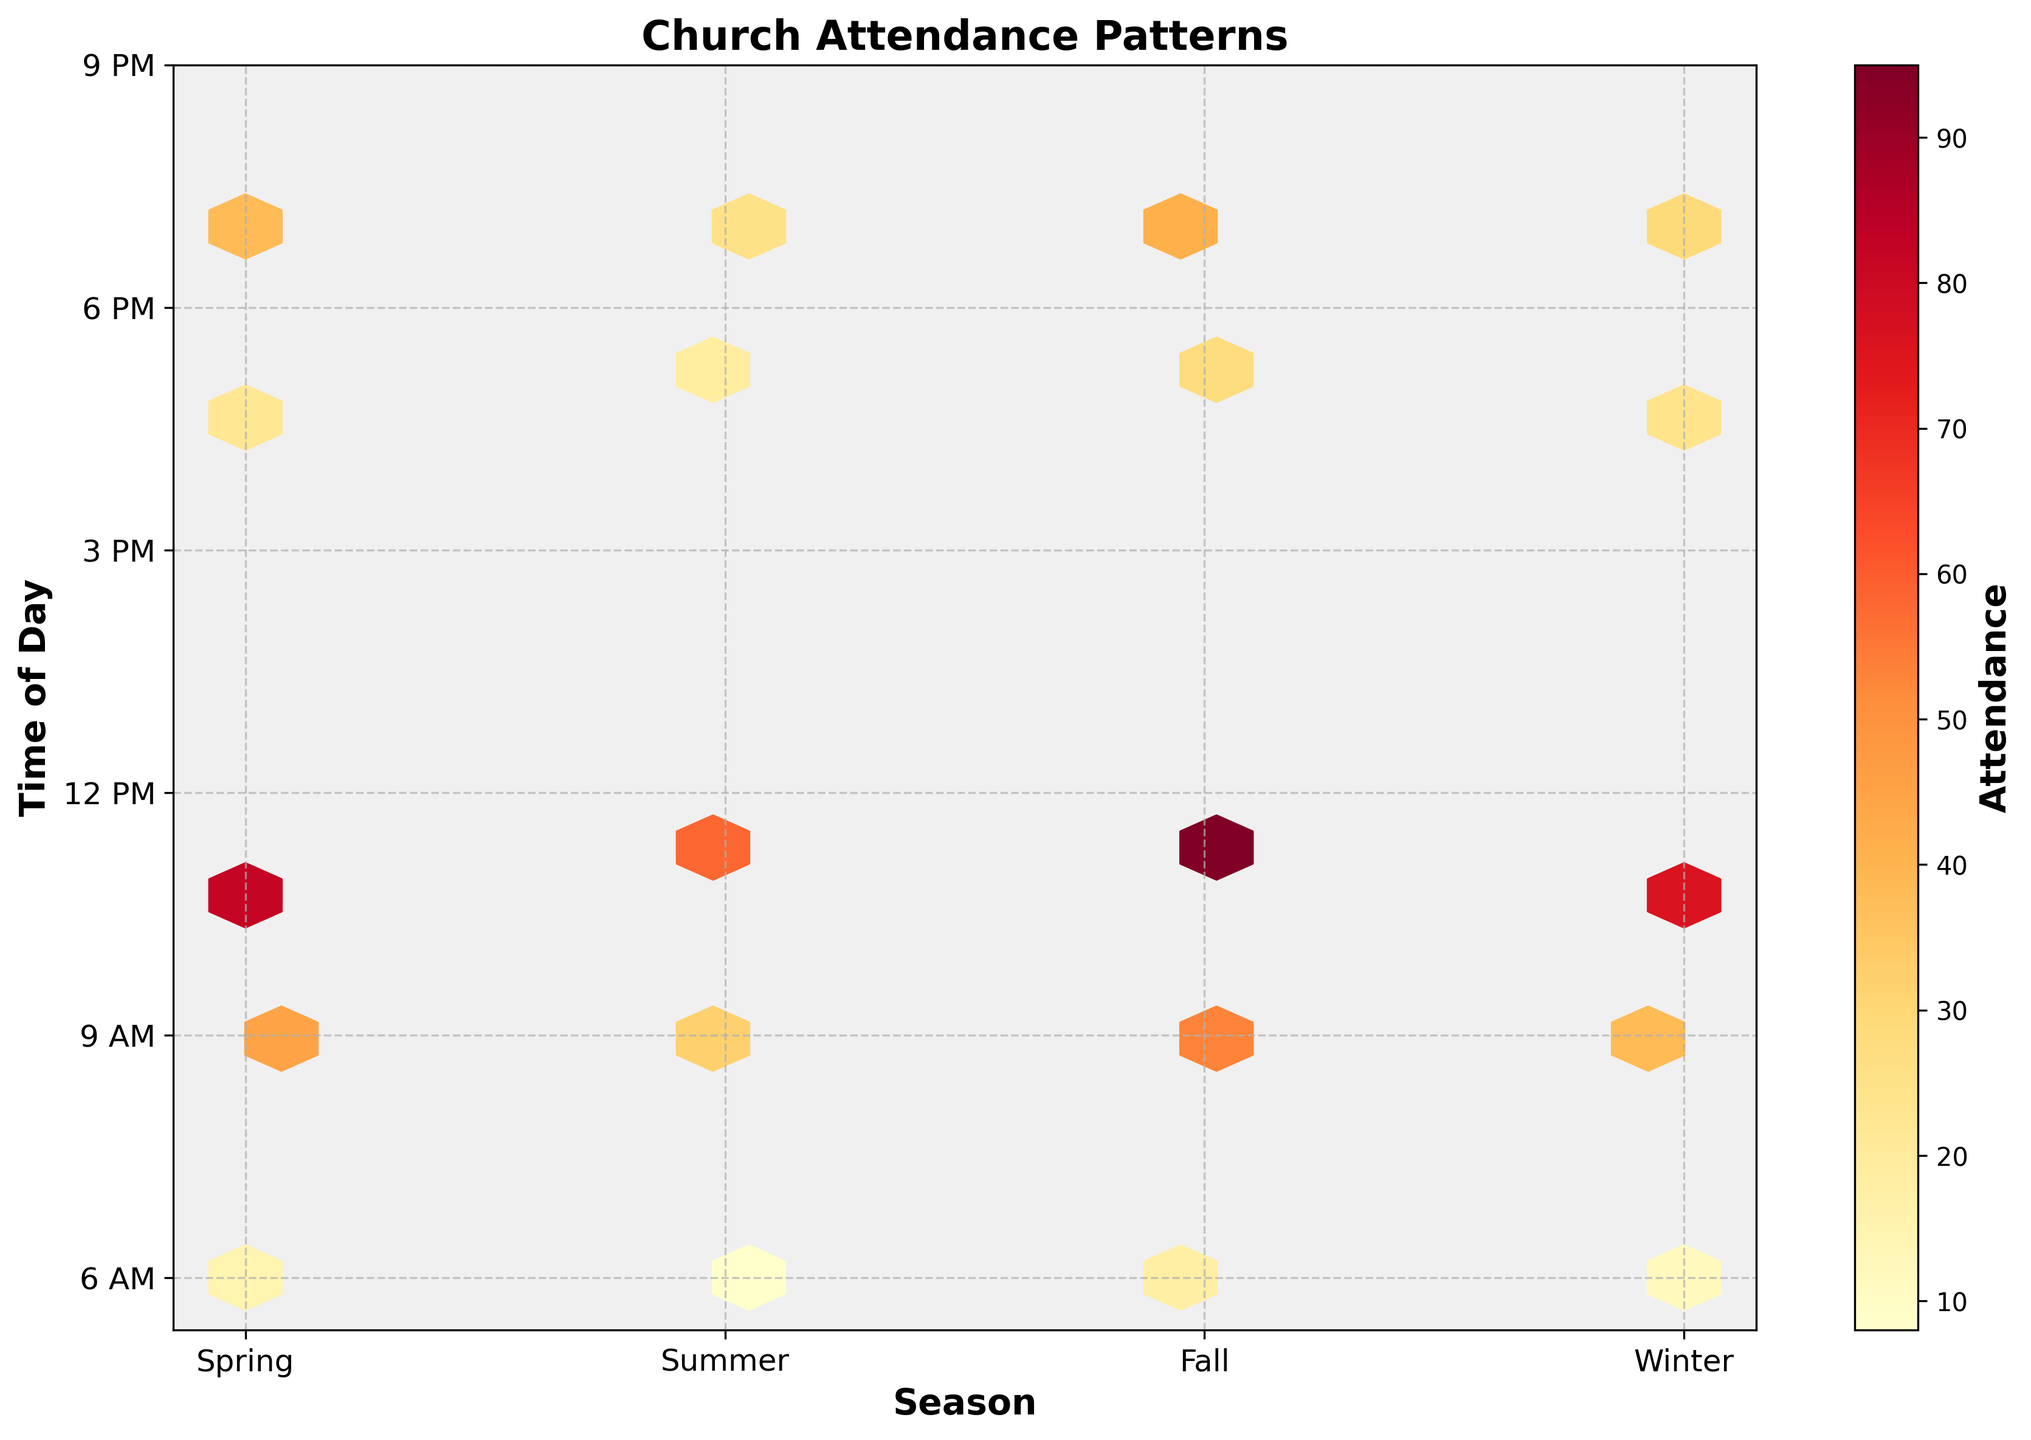How do the attendance patterns vary across seasons? By observing the hexbin plot, we can see that the brightest (yellow) areas representing the highest attendance are mainly concentrated during Fall at 11:00 AM. Spring and Winter also show good attendance during the 11:00 AM service, while Summer has relatively lower attendance.
Answer: Fall sees the highest attendance at 11:00 AM Which time of day generally has the highest attendance across all seasons? Looking at the color gradient on the hexbin plot, the 11:00 AM time slot shows the brightest colors across all seasons, indicating the highest attendance compared to other times.
Answer: 11:00 AM Are there any time slots with consistently low attendance? The hexbin plot shows darker hexagons for the 6:00 AM and 7:00 PM time slots across all seasons, indicating lower attendance.
Answer: 6:00 AM and 7:00 PM In which season is the 9:00 AM attendance highest, and how can you tell? By comparing the brightness of the hexagon for the 9:00 AM time slot across all seasons, Fall shows the brightest hexagon, indicating the highest attendance at this time.
Answer: Fall Is there a significant difference in attendance between morning and evening services during Summer? The hexbin plot shows brighter colors (higher attendance) for morning services (9:00 AM and 11:00 AM) compared to the evening service (7:00 PM) during Summer. This indicates higher attendance in the morning.
Answer: Yes, morning services have higher attendance How does Winter attendance for the 7:00 PM service compare to Fall? The hexagon for the 7:00 PM service in Winter is darker than in Fall, indicating lower attendance in Winter compared to Fall for that time slot.
Answer: Lower in Winter What season and time have the lowest recorded attendance? Observing the hexbin plot, the darkest hexagons indicating the lowest attendance are located at 6:00 AM during Summer.
Answer: 6:00 AM in Summer How does Spring 5:00 PM attendance compare to Winter 5:00 PM attendance? The hexagon for the 5:00 PM service in Winter is slightly brighter than the one in Spring, which indicates higher attendance in Winter for this time slot.
Answer: Higher in Winter Which season has the most evenly distributed attendance throughout the day? By observing the color distribution on the hexbin plot, Spring shows a more even distribution of colors across various times, suggesting a relatively balanced attendance throughout the day.
Answer: Spring Are evening services generally less attended than morning and midday services? Across most seasons, the evening services (5:00 PM and 7:00 PM) have darker hexagons compared to morning (9:00 AM) and midday (11:00 AM) services, indicating generally lower attendance.
Answer: Yes 